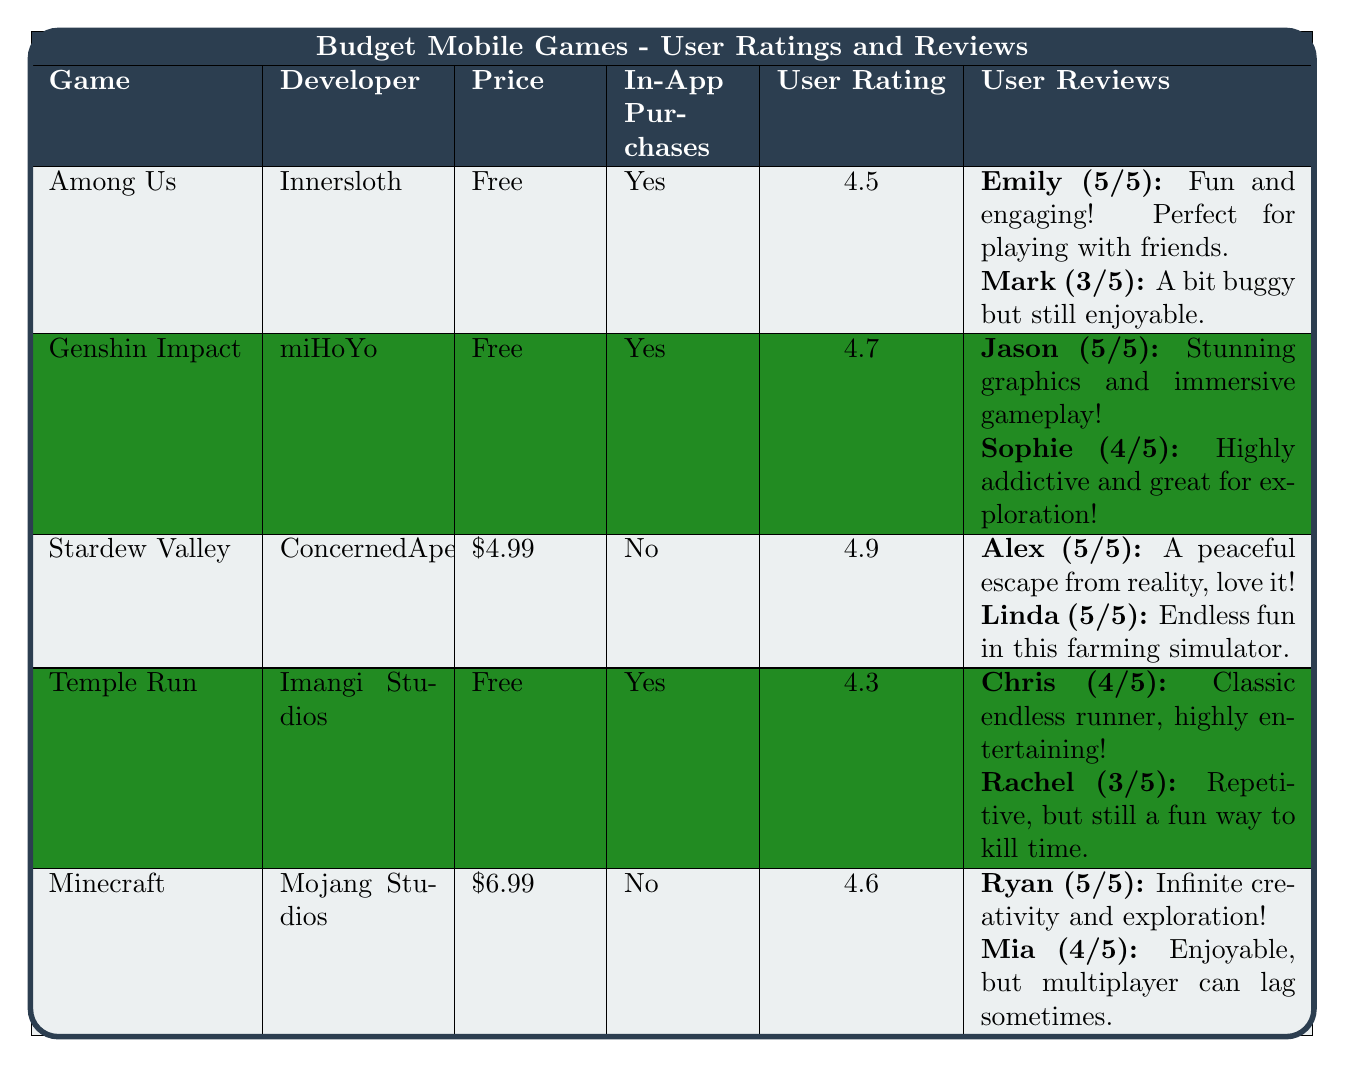What is the user rating of Stardew Valley? The user rating for Stardew Valley is listed in the table under the "User Rating" column. It shows a value of 4.9.
Answer: 4.9 Which game has the highest user rating? By comparing the user ratings in the "User Rating" column, Stardew Valley has the highest rating at 4.9.
Answer: Stardew Valley Is Among Us a paid game? The price of Among Us is mentioned in the "Price" column as "Free", indicating it does not require payment to download.
Answer: No How many user reviews does Genshin Impact have? The table provides two user reviews for Genshin Impact, which can be counted in the "User Reviews" column.
Answer: 2 Which game has the lowest user rating? Observing the user ratings, Temple Run has the lowest rating at 4.3.
Answer: Temple Run Are there any games listed that do not have in-app purchases? The "In-App Purchases" column reveals that Stardew Valley and Minecraft both have "No" listed, indicating they do not offer in-app purchases.
Answer: Yes What is the average user rating of the games listed? The user ratings of the games are 4.5, 4.7, 4.9, 4.3, and 4.6. Adding these gives 4.5 + 4.7 + 4.9 + 4.3 + 4.6 = 24. The average is 24 divided by 5, which is 4.8.
Answer: 4.8 Do all the games listed have in-app purchases? By checking the "In-App Purchases" column, it is noted that both Stardew Valley and Minecraft do not have in-app purchases while others do.
Answer: No What is the average rating of the user reviews for Minecraft? Minecraft has two user reviews with ratings of 5 and 4. The average rating is calculated as (5 + 4) / 2 = 4.5.
Answer: 4.5 Which game's reviews mention a significant issue and what is it? In the user reviews for Among Us, Mark describes an issue by stating the game is "A bit buggy but still enjoyable," indicating some problems.
Answer: Buggy performance How many games have a user rating of 4.5 or higher? All games listed have a user rating of 4.3 or higher; specifically, Among Us (4.5), Genshin Impact (4.7), Stardew Valley (4.9), Temple Run (4.3), and Minecraft (4.6) give a total of 5 games.
Answer: 5 